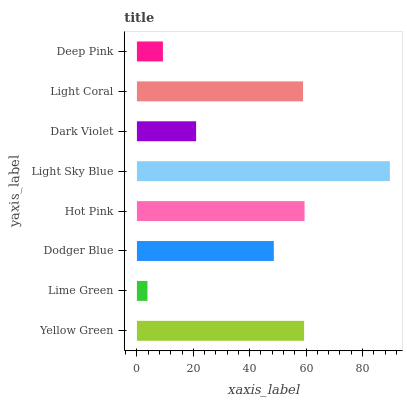Is Lime Green the minimum?
Answer yes or no. Yes. Is Light Sky Blue the maximum?
Answer yes or no. Yes. Is Dodger Blue the minimum?
Answer yes or no. No. Is Dodger Blue the maximum?
Answer yes or no. No. Is Dodger Blue greater than Lime Green?
Answer yes or no. Yes. Is Lime Green less than Dodger Blue?
Answer yes or no. Yes. Is Lime Green greater than Dodger Blue?
Answer yes or no. No. Is Dodger Blue less than Lime Green?
Answer yes or no. No. Is Light Coral the high median?
Answer yes or no. Yes. Is Dodger Blue the low median?
Answer yes or no. Yes. Is Dodger Blue the high median?
Answer yes or no. No. Is Light Sky Blue the low median?
Answer yes or no. No. 